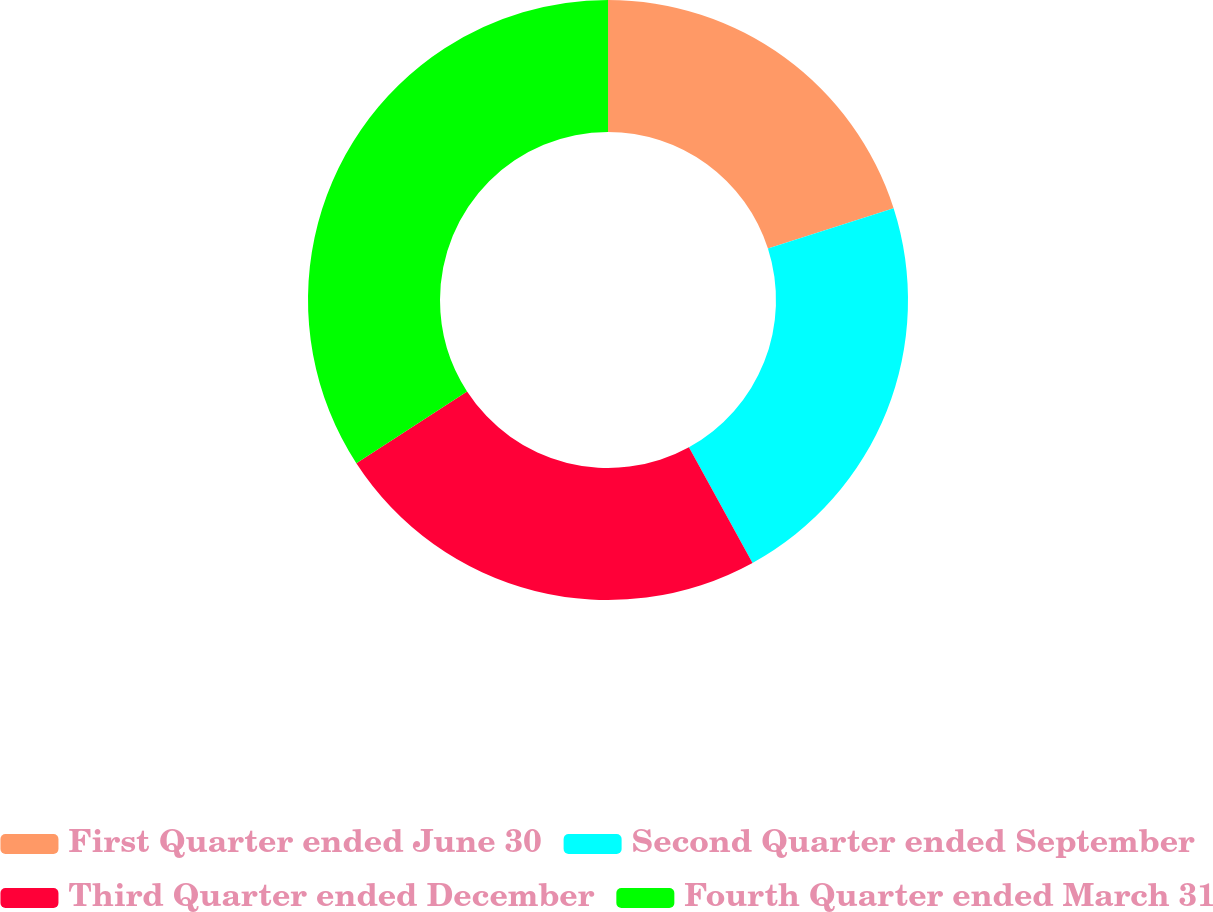Convert chart to OTSL. <chart><loc_0><loc_0><loc_500><loc_500><pie_chart><fcel>First Quarter ended June 30<fcel>Second Quarter ended September<fcel>Third Quarter ended December<fcel>Fourth Quarter ended March 31<nl><fcel>20.05%<fcel>21.95%<fcel>23.84%<fcel>34.16%<nl></chart> 